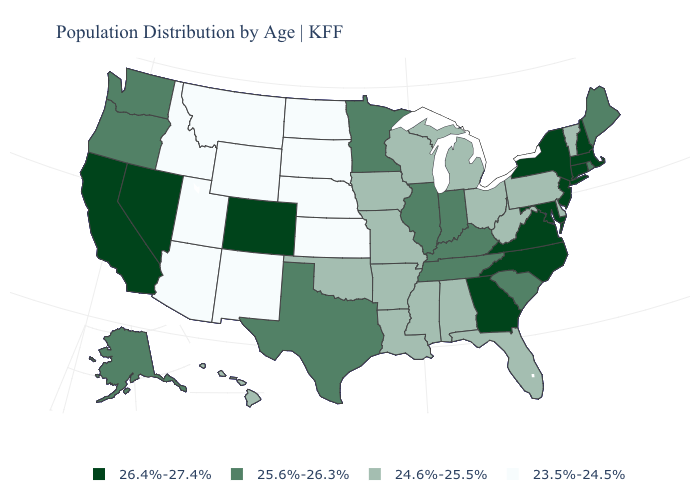Does the first symbol in the legend represent the smallest category?
Be succinct. No. What is the value of Oklahoma?
Give a very brief answer. 24.6%-25.5%. What is the highest value in states that border Maine?
Be succinct. 26.4%-27.4%. Does South Dakota have a higher value than Connecticut?
Write a very short answer. No. Name the states that have a value in the range 26.4%-27.4%?
Answer briefly. California, Colorado, Connecticut, Georgia, Maryland, Massachusetts, Nevada, New Hampshire, New Jersey, New York, North Carolina, Virginia. Among the states that border New York , which have the highest value?
Short answer required. Connecticut, Massachusetts, New Jersey. How many symbols are there in the legend?
Answer briefly. 4. Name the states that have a value in the range 24.6%-25.5%?
Answer briefly. Alabama, Arkansas, Delaware, Florida, Hawaii, Iowa, Louisiana, Michigan, Mississippi, Missouri, Ohio, Oklahoma, Pennsylvania, Vermont, West Virginia, Wisconsin. Which states hav the highest value in the MidWest?
Write a very short answer. Illinois, Indiana, Minnesota. Name the states that have a value in the range 25.6%-26.3%?
Be succinct. Alaska, Illinois, Indiana, Kentucky, Maine, Minnesota, Oregon, Rhode Island, South Carolina, Tennessee, Texas, Washington. Does New Jersey have a higher value than North Carolina?
Answer briefly. No. What is the value of Kentucky?
Keep it brief. 25.6%-26.3%. Does North Carolina have a higher value than Massachusetts?
Short answer required. No. What is the value of Colorado?
Concise answer only. 26.4%-27.4%. Does Maryland have the highest value in the South?
Concise answer only. Yes. 